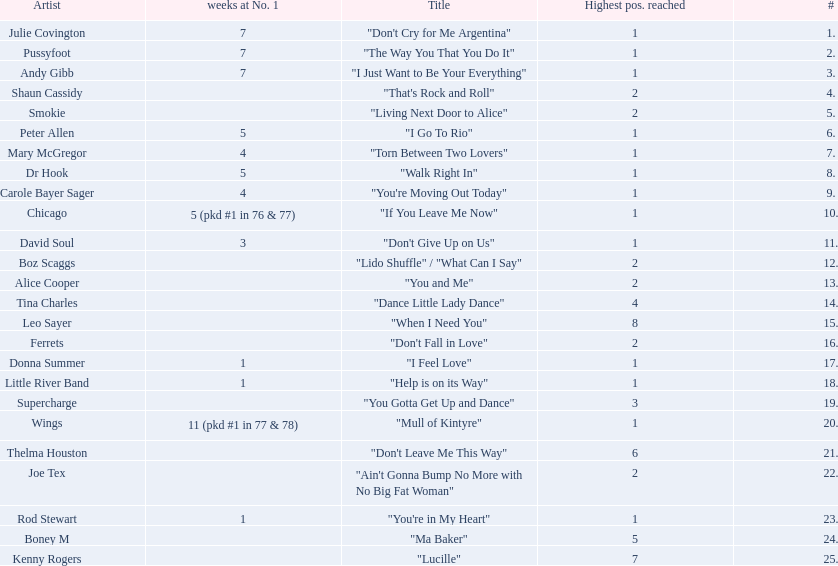Which artists were included in the top 25 singles for 1977 in australia? Julie Covington, Pussyfoot, Andy Gibb, Shaun Cassidy, Smokie, Peter Allen, Mary McGregor, Dr Hook, Carole Bayer Sager, Chicago, David Soul, Boz Scaggs, Alice Cooper, Tina Charles, Leo Sayer, Ferrets, Donna Summer, Little River Band, Supercharge, Wings, Thelma Houston, Joe Tex, Rod Stewart, Boney M, Kenny Rogers. And for how many weeks did they chart at number 1? 7, 7, 7, , , 5, 4, 5, 4, 5 (pkd #1 in 76 & 77), 3, , , , , , 1, 1, , 11 (pkd #1 in 77 & 78), , , 1, , . Which artist was in the number 1 spot for most time? Wings. 